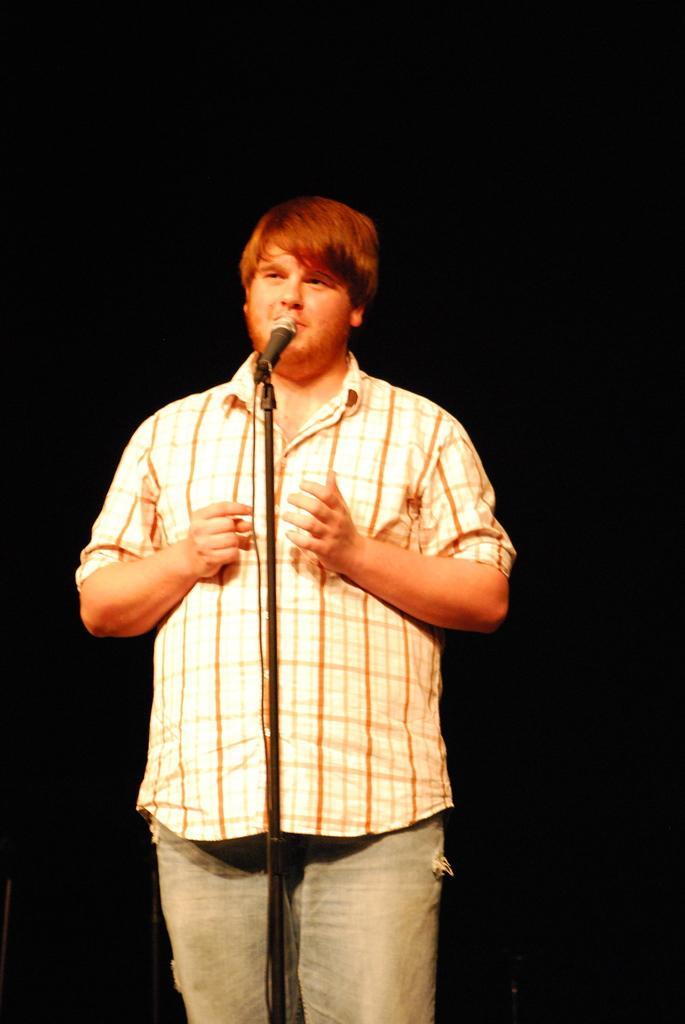Could you give a brief overview of what you see in this image? This picture is taken in the dark. I can see a person standing in front of a mike.  